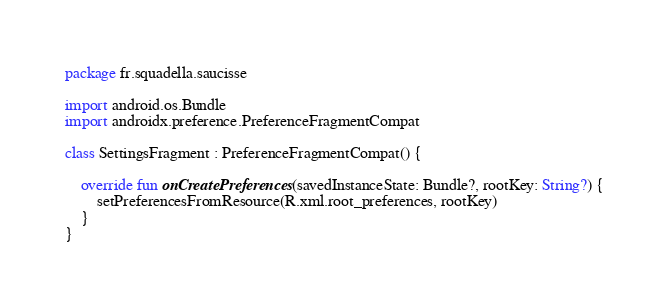Convert code to text. <code><loc_0><loc_0><loc_500><loc_500><_Kotlin_>package fr.squadella.saucisse

import android.os.Bundle
import androidx.preference.PreferenceFragmentCompat

class SettingsFragment : PreferenceFragmentCompat() {

    override fun onCreatePreferences(savedInstanceState: Bundle?, rootKey: String?) {
        setPreferencesFromResource(R.xml.root_preferences, rootKey)
    }
}</code> 